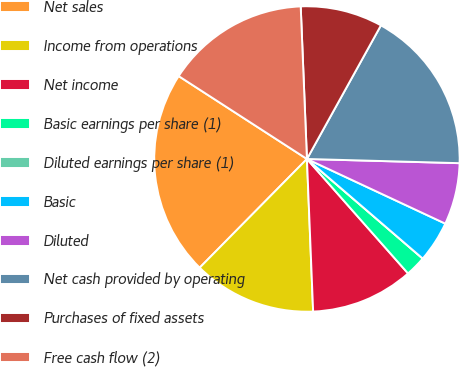Convert chart. <chart><loc_0><loc_0><loc_500><loc_500><pie_chart><fcel>Net sales<fcel>Income from operations<fcel>Net income<fcel>Basic earnings per share (1)<fcel>Diluted earnings per share (1)<fcel>Basic<fcel>Diluted<fcel>Net cash provided by operating<fcel>Purchases of fixed assets<fcel>Free cash flow (2)<nl><fcel>21.74%<fcel>13.04%<fcel>10.87%<fcel>2.18%<fcel>0.0%<fcel>4.35%<fcel>6.52%<fcel>17.39%<fcel>8.7%<fcel>15.22%<nl></chart> 